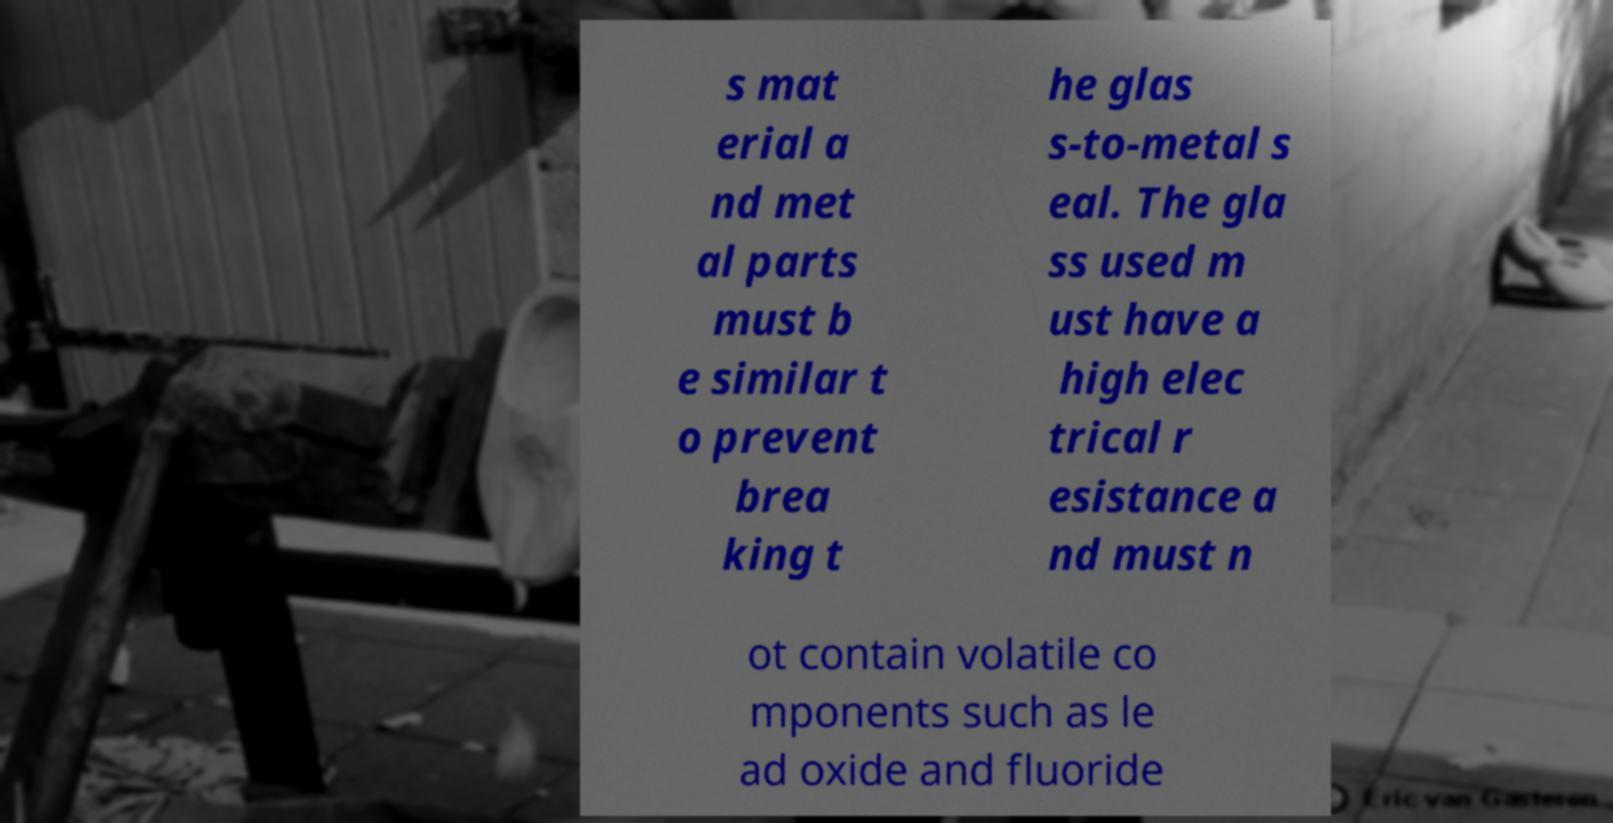I need the written content from this picture converted into text. Can you do that? s mat erial a nd met al parts must b e similar t o prevent brea king t he glas s-to-metal s eal. The gla ss used m ust have a high elec trical r esistance a nd must n ot contain volatile co mponents such as le ad oxide and fluoride 